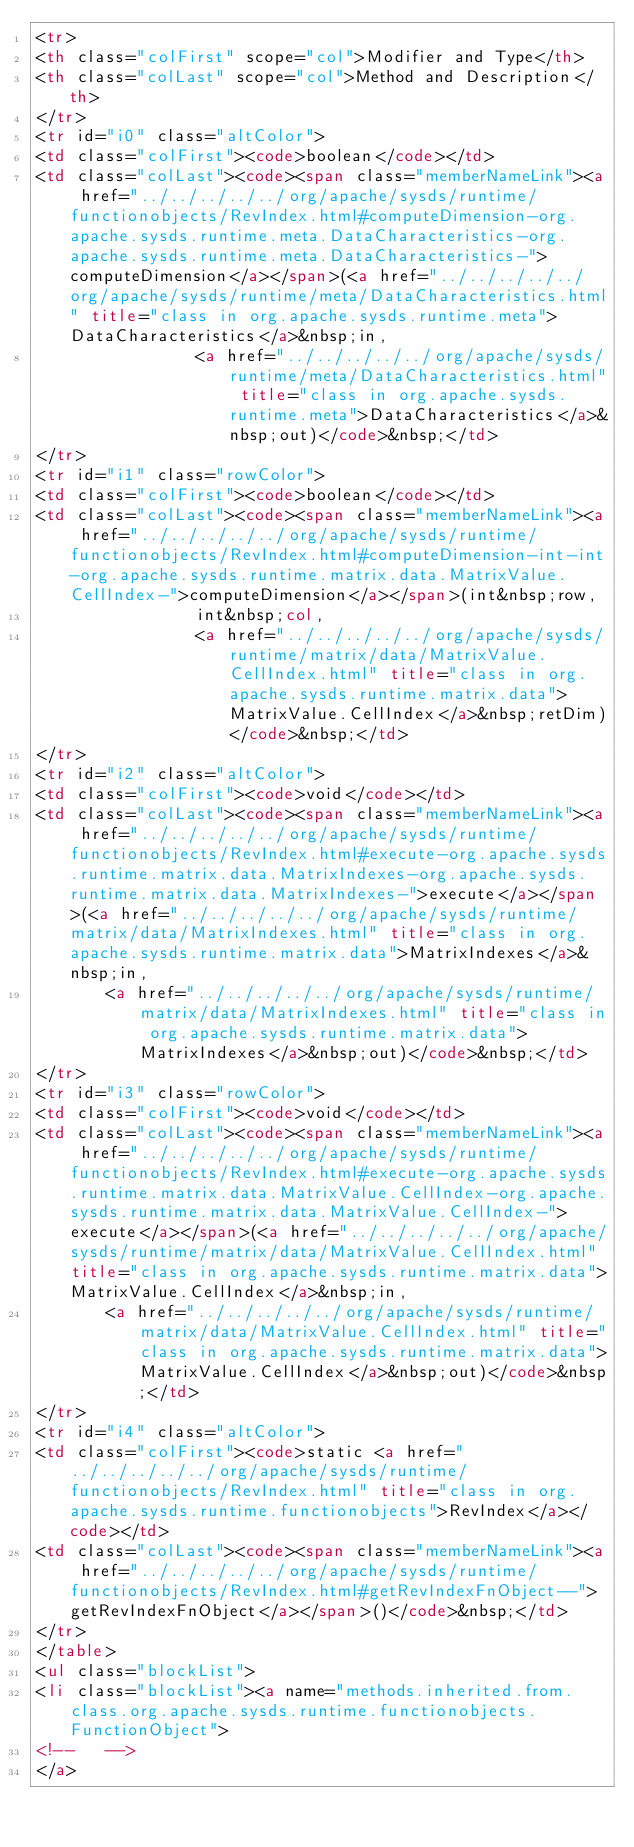Convert code to text. <code><loc_0><loc_0><loc_500><loc_500><_HTML_><tr>
<th class="colFirst" scope="col">Modifier and Type</th>
<th class="colLast" scope="col">Method and Description</th>
</tr>
<tr id="i0" class="altColor">
<td class="colFirst"><code>boolean</code></td>
<td class="colLast"><code><span class="memberNameLink"><a href="../../../../../org/apache/sysds/runtime/functionobjects/RevIndex.html#computeDimension-org.apache.sysds.runtime.meta.DataCharacteristics-org.apache.sysds.runtime.meta.DataCharacteristics-">computeDimension</a></span>(<a href="../../../../../org/apache/sysds/runtime/meta/DataCharacteristics.html" title="class in org.apache.sysds.runtime.meta">DataCharacteristics</a>&nbsp;in,
                <a href="../../../../../org/apache/sysds/runtime/meta/DataCharacteristics.html" title="class in org.apache.sysds.runtime.meta">DataCharacteristics</a>&nbsp;out)</code>&nbsp;</td>
</tr>
<tr id="i1" class="rowColor">
<td class="colFirst"><code>boolean</code></td>
<td class="colLast"><code><span class="memberNameLink"><a href="../../../../../org/apache/sysds/runtime/functionobjects/RevIndex.html#computeDimension-int-int-org.apache.sysds.runtime.matrix.data.MatrixValue.CellIndex-">computeDimension</a></span>(int&nbsp;row,
                int&nbsp;col,
                <a href="../../../../../org/apache/sysds/runtime/matrix/data/MatrixValue.CellIndex.html" title="class in org.apache.sysds.runtime.matrix.data">MatrixValue.CellIndex</a>&nbsp;retDim)</code>&nbsp;</td>
</tr>
<tr id="i2" class="altColor">
<td class="colFirst"><code>void</code></td>
<td class="colLast"><code><span class="memberNameLink"><a href="../../../../../org/apache/sysds/runtime/functionobjects/RevIndex.html#execute-org.apache.sysds.runtime.matrix.data.MatrixIndexes-org.apache.sysds.runtime.matrix.data.MatrixIndexes-">execute</a></span>(<a href="../../../../../org/apache/sysds/runtime/matrix/data/MatrixIndexes.html" title="class in org.apache.sysds.runtime.matrix.data">MatrixIndexes</a>&nbsp;in,
       <a href="../../../../../org/apache/sysds/runtime/matrix/data/MatrixIndexes.html" title="class in org.apache.sysds.runtime.matrix.data">MatrixIndexes</a>&nbsp;out)</code>&nbsp;</td>
</tr>
<tr id="i3" class="rowColor">
<td class="colFirst"><code>void</code></td>
<td class="colLast"><code><span class="memberNameLink"><a href="../../../../../org/apache/sysds/runtime/functionobjects/RevIndex.html#execute-org.apache.sysds.runtime.matrix.data.MatrixValue.CellIndex-org.apache.sysds.runtime.matrix.data.MatrixValue.CellIndex-">execute</a></span>(<a href="../../../../../org/apache/sysds/runtime/matrix/data/MatrixValue.CellIndex.html" title="class in org.apache.sysds.runtime.matrix.data">MatrixValue.CellIndex</a>&nbsp;in,
       <a href="../../../../../org/apache/sysds/runtime/matrix/data/MatrixValue.CellIndex.html" title="class in org.apache.sysds.runtime.matrix.data">MatrixValue.CellIndex</a>&nbsp;out)</code>&nbsp;</td>
</tr>
<tr id="i4" class="altColor">
<td class="colFirst"><code>static <a href="../../../../../org/apache/sysds/runtime/functionobjects/RevIndex.html" title="class in org.apache.sysds.runtime.functionobjects">RevIndex</a></code></td>
<td class="colLast"><code><span class="memberNameLink"><a href="../../../../../org/apache/sysds/runtime/functionobjects/RevIndex.html#getRevIndexFnObject--">getRevIndexFnObject</a></span>()</code>&nbsp;</td>
</tr>
</table>
<ul class="blockList">
<li class="blockList"><a name="methods.inherited.from.class.org.apache.sysds.runtime.functionobjects.FunctionObject">
<!--   -->
</a></code> 